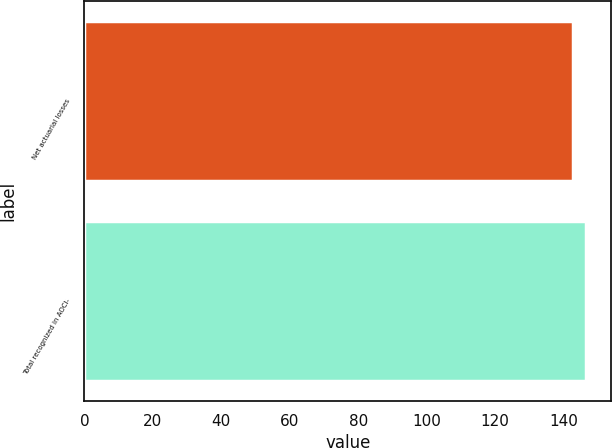<chart> <loc_0><loc_0><loc_500><loc_500><bar_chart><fcel>Net actuarial losses<fcel>Total recognized in AOCI-<nl><fcel>142.7<fcel>146.7<nl></chart> 